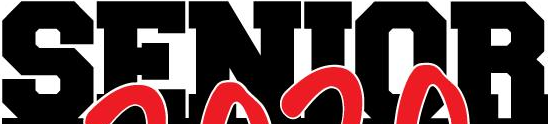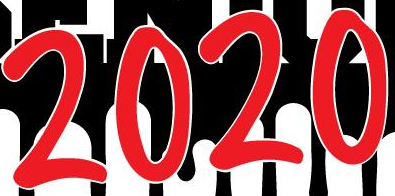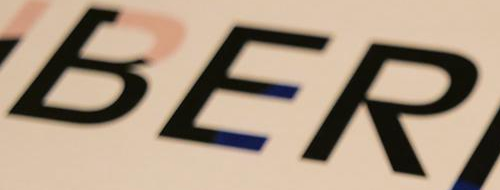Identify the words shown in these images in order, separated by a semicolon. SENIOR; 2020; BER 